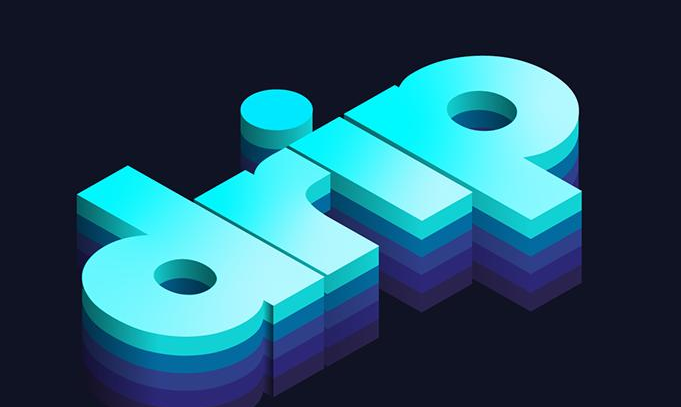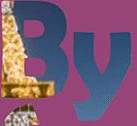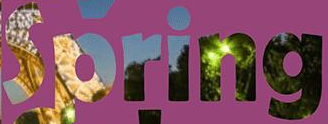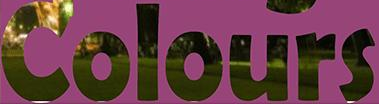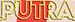Read the text from these images in sequence, separated by a semicolon. drip; By; Spring; Colours; PUTRA 